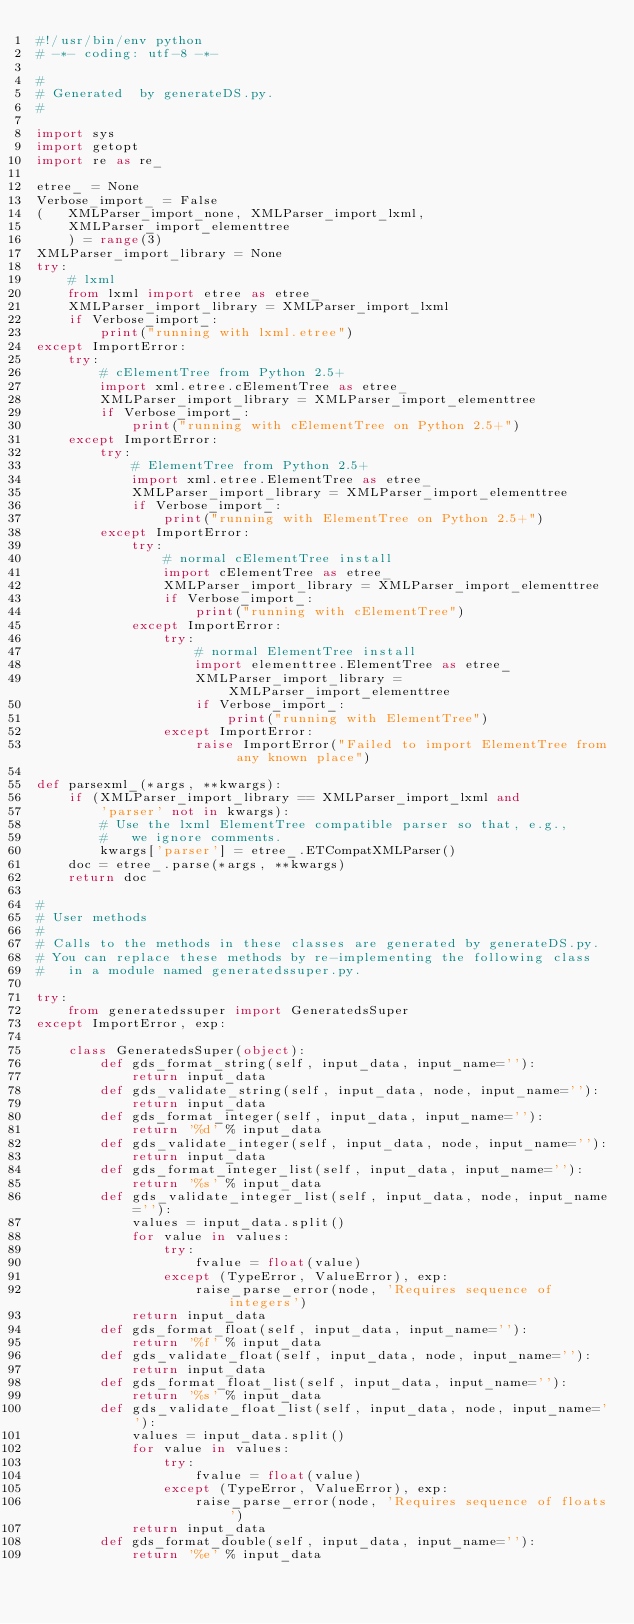<code> <loc_0><loc_0><loc_500><loc_500><_Python_>#!/usr/bin/env python
# -*- coding: utf-8 -*- 

#
# Generated  by generateDS.py.
#

import sys
import getopt
import re as re_

etree_ = None
Verbose_import_ = False
(   XMLParser_import_none, XMLParser_import_lxml,
    XMLParser_import_elementtree
    ) = range(3)
XMLParser_import_library = None
try:
    # lxml
    from lxml import etree as etree_
    XMLParser_import_library = XMLParser_import_lxml
    if Verbose_import_:
        print("running with lxml.etree")
except ImportError:
    try:
        # cElementTree from Python 2.5+
        import xml.etree.cElementTree as etree_
        XMLParser_import_library = XMLParser_import_elementtree
        if Verbose_import_:
            print("running with cElementTree on Python 2.5+")
    except ImportError:
        try:
            # ElementTree from Python 2.5+
            import xml.etree.ElementTree as etree_
            XMLParser_import_library = XMLParser_import_elementtree
            if Verbose_import_:
                print("running with ElementTree on Python 2.5+")
        except ImportError:
            try:
                # normal cElementTree install
                import cElementTree as etree_
                XMLParser_import_library = XMLParser_import_elementtree
                if Verbose_import_:
                    print("running with cElementTree")
            except ImportError:
                try:
                    # normal ElementTree install
                    import elementtree.ElementTree as etree_
                    XMLParser_import_library = XMLParser_import_elementtree
                    if Verbose_import_:
                        print("running with ElementTree")
                except ImportError:
                    raise ImportError("Failed to import ElementTree from any known place")

def parsexml_(*args, **kwargs):
    if (XMLParser_import_library == XMLParser_import_lxml and
        'parser' not in kwargs):
        # Use the lxml ElementTree compatible parser so that, e.g.,
        #   we ignore comments.
        kwargs['parser'] = etree_.ETCompatXMLParser()
    doc = etree_.parse(*args, **kwargs)
    return doc

#
# User methods
#
# Calls to the methods in these classes are generated by generateDS.py.
# You can replace these methods by re-implementing the following class
#   in a module named generatedssuper.py.

try:
    from generatedssuper import GeneratedsSuper
except ImportError, exp:

    class GeneratedsSuper(object):
        def gds_format_string(self, input_data, input_name=''):
            return input_data
        def gds_validate_string(self, input_data, node, input_name=''):
            return input_data
        def gds_format_integer(self, input_data, input_name=''):
            return '%d' % input_data
        def gds_validate_integer(self, input_data, node, input_name=''):
            return input_data
        def gds_format_integer_list(self, input_data, input_name=''):
            return '%s' % input_data
        def gds_validate_integer_list(self, input_data, node, input_name=''):
            values = input_data.split()
            for value in values:
                try:
                    fvalue = float(value)
                except (TypeError, ValueError), exp:
                    raise_parse_error(node, 'Requires sequence of integers')
            return input_data
        def gds_format_float(self, input_data, input_name=''):
            return '%f' % input_data
        def gds_validate_float(self, input_data, node, input_name=''):
            return input_data
        def gds_format_float_list(self, input_data, input_name=''):
            return '%s' % input_data
        def gds_validate_float_list(self, input_data, node, input_name=''):
            values = input_data.split()
            for value in values:
                try:
                    fvalue = float(value)
                except (TypeError, ValueError), exp:
                    raise_parse_error(node, 'Requires sequence of floats')
            return input_data
        def gds_format_double(self, input_data, input_name=''):
            return '%e' % input_data</code> 